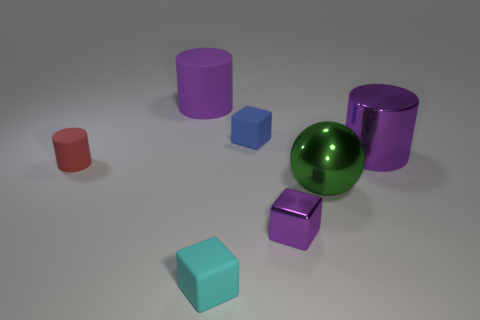What shape is the purple thing that is the same size as the purple rubber cylinder?
Provide a succinct answer. Cylinder. What number of other objects are there of the same color as the tiny metal object?
Your answer should be compact. 2. What number of other things are there of the same material as the small cylinder
Your response must be concise. 3. There is a blue object; does it have the same size as the cyan rubber cube on the right side of the big rubber cylinder?
Offer a very short reply. Yes. What is the color of the tiny metal cube?
Make the answer very short. Purple. There is a purple metallic thing that is in front of the rubber cylinder that is on the left side of the big purple object on the left side of the tiny purple cube; what is its shape?
Offer a very short reply. Cube. There is a red cylinder that is in front of the large thing that is left of the tiny purple object; what is its material?
Offer a very short reply. Rubber. There is a large purple thing that is made of the same material as the purple block; what is its shape?
Your answer should be compact. Cylinder. Are there any other things that have the same shape as the green object?
Ensure brevity in your answer.  No. What number of green objects are left of the cyan rubber block?
Keep it short and to the point. 0. 